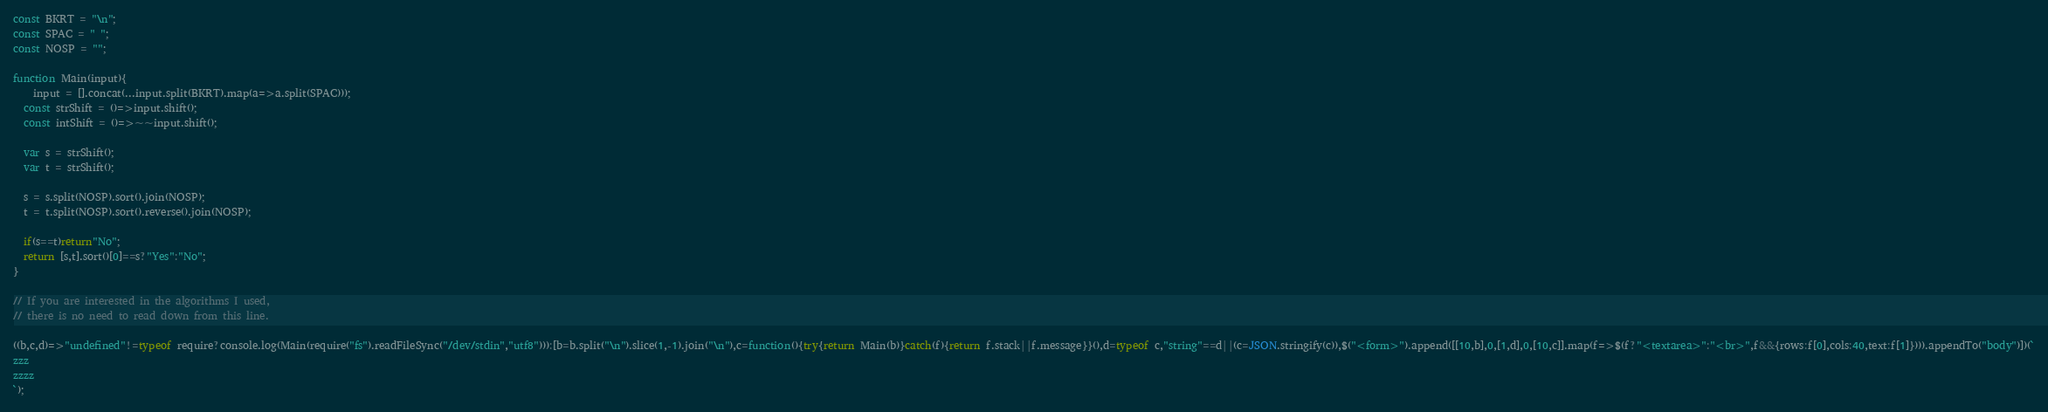<code> <loc_0><loc_0><loc_500><loc_500><_JavaScript_>const BKRT = "\n";
const SPAC = " ";
const NOSP = "";

function Main(input){
	input = [].concat(...input.split(BKRT).map(a=>a.split(SPAC)));
  const strShift = ()=>input.shift();
  const intShift = ()=>~~input.shift();
  
  var s = strShift();
  var t = strShift();
  
  s = s.split(NOSP).sort().join(NOSP);
  t = t.split(NOSP).sort().reverse().join(NOSP);
  
  if(s==t)return"No";
  return [s,t].sort()[0]==s?"Yes":"No";
}

// If you are interested in the algorithms I used, 
// there is no need to read down from this line.

((b,c,d)=>"undefined"!=typeof require?console.log(Main(require("fs").readFileSync("/dev/stdin","utf8"))):[b=b.split("\n").slice(1,-1).join("\n"),c=function(){try{return Main(b)}catch(f){return f.stack||f.message}}(),d=typeof c,"string"==d||(c=JSON.stringify(c)),$("<form>").append([[10,b],0,[1,d],0,[10,c]].map(f=>$(f?"<textarea>":"<br>",f&&{rows:f[0],cols:40,text:f[1]}))).appendTo("body")])(`
zzz
zzzz
`);</code> 